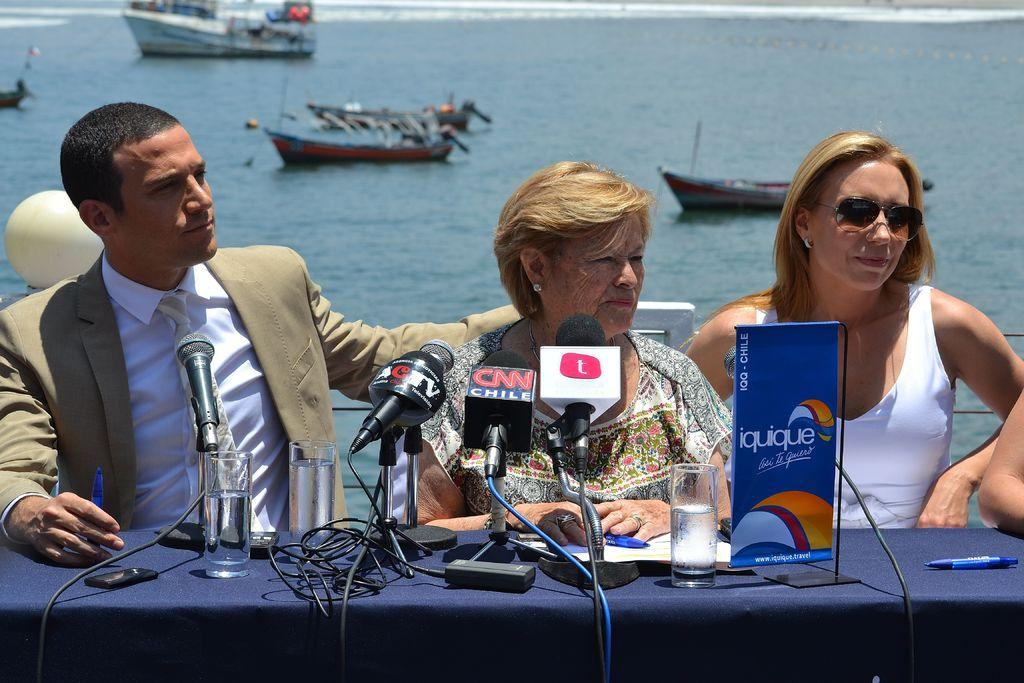What is the main piece of furniture in the image? There is a table in the image. What items can be seen on the table? There are microphones, glasses, and other objects on the table. How many people are in the image? There are three people in the image. What is in the foreground of the image? There are chairs in the foreground. What can be seen in the background of the image? There is water visible in the background, and there are ships in the background. What type of quiver can be seen in the image? There is no quiver present in the image. How does the approval rating of the people in the image change throughout the scene? The image does not depict a scene with changing approval ratings; it is a still image. 